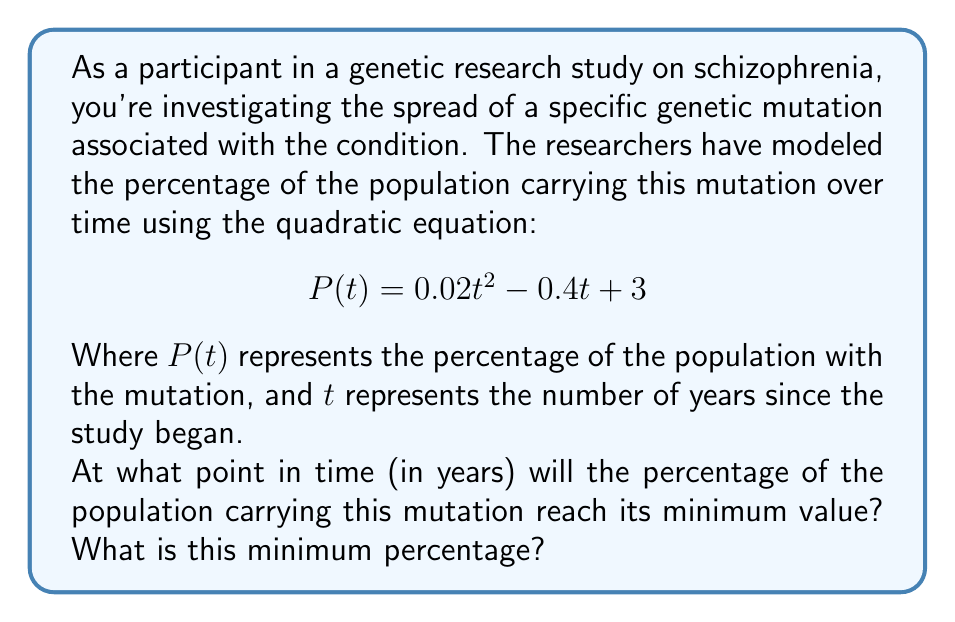Can you solve this math problem? To solve this problem, we'll follow these steps:

1) The quadratic equation given is in the form $f(x) = ax^2 + bx + c$, where:
   $a = 0.02$
   $b = -0.4$
   $c = 3$

2) For a quadratic function, the vertex represents either the minimum or maximum point. Since $a > 0$, this parabola opens upward, so the vertex will be the minimum point.

3) To find the x-coordinate of the vertex (which represents the time at which the minimum occurs), we use the formula:

   $$ t = -\frac{b}{2a} $$

4) Substituting our values:

   $$ t = -\frac{-0.4}{2(0.02)} = \frac{0.4}{0.04} = 10 $$

5) So the minimum occurs at $t = 10$ years.

6) To find the minimum percentage, we substitute $t = 10$ into our original equation:

   $$ P(10) = 0.02(10)^2 - 0.4(10) + 3 $$
   $$ = 0.02(100) - 4 + 3 $$
   $$ = 2 - 4 + 3 = 1 $$

Therefore, the minimum percentage occurs 10 years after the start of the study, and the minimum percentage is 1%.
Answer: The minimum percentage of the population carrying the mutation occurs 10 years after the start of the study, and the minimum percentage is 1%. 